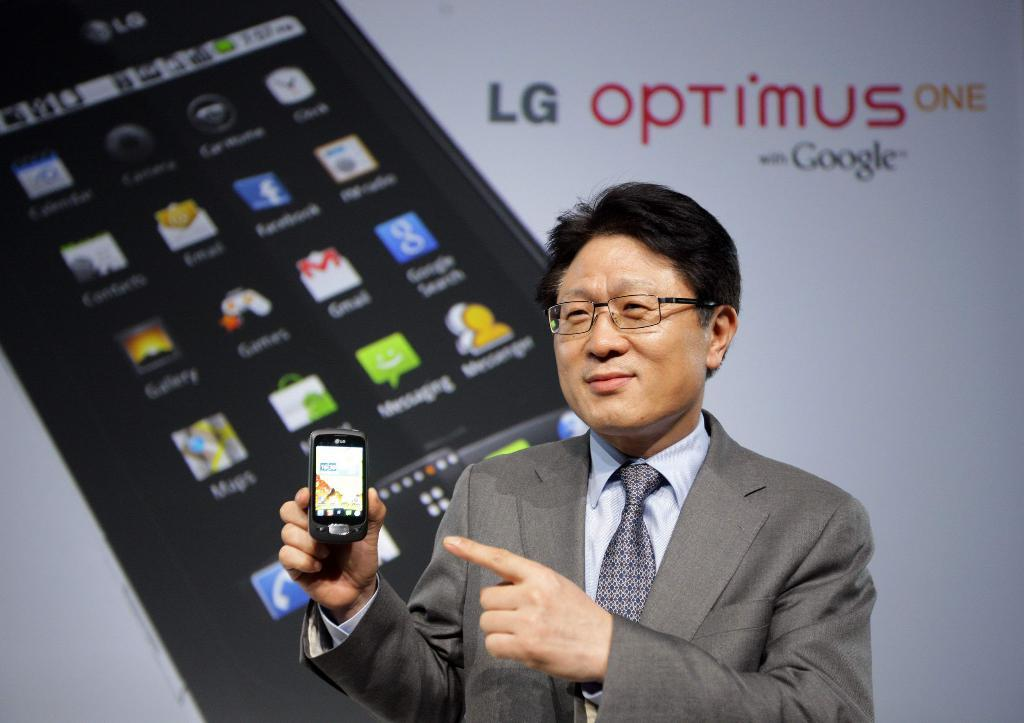<image>
Describe the image concisely. A man in a suit with glasses is pointing to a cell phone and an ad behind him says LG optimus one. 